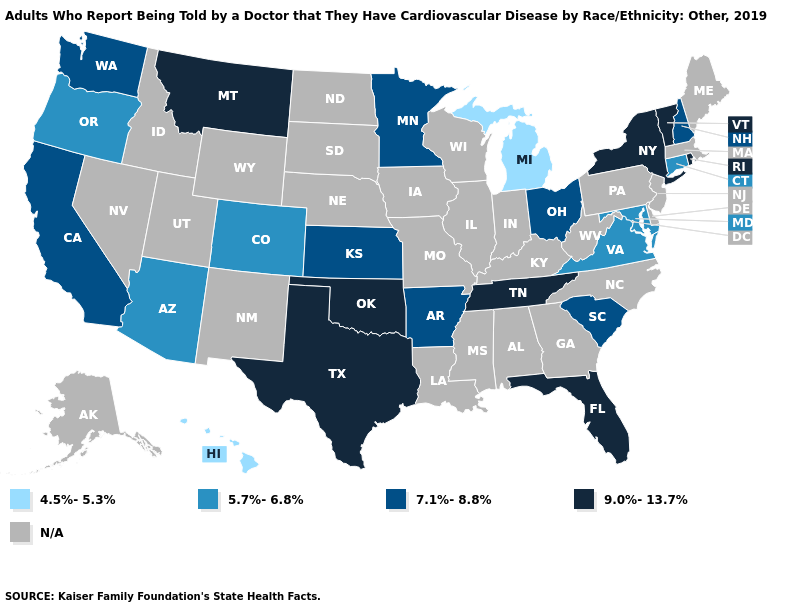What is the lowest value in the USA?
Be succinct. 4.5%-5.3%. Name the states that have a value in the range 7.1%-8.8%?
Concise answer only. Arkansas, California, Kansas, Minnesota, New Hampshire, Ohio, South Carolina, Washington. Does Minnesota have the lowest value in the MidWest?
Concise answer only. No. What is the value of Nebraska?
Be succinct. N/A. Name the states that have a value in the range 9.0%-13.7%?
Concise answer only. Florida, Montana, New York, Oklahoma, Rhode Island, Tennessee, Texas, Vermont. What is the value of Indiana?
Answer briefly. N/A. Does the map have missing data?
Write a very short answer. Yes. Name the states that have a value in the range 5.7%-6.8%?
Write a very short answer. Arizona, Colorado, Connecticut, Maryland, Oregon, Virginia. What is the highest value in states that border Rhode Island?
Answer briefly. 5.7%-6.8%. Does the first symbol in the legend represent the smallest category?
Short answer required. Yes. Name the states that have a value in the range 7.1%-8.8%?
Short answer required. Arkansas, California, Kansas, Minnesota, New Hampshire, Ohio, South Carolina, Washington. Does the first symbol in the legend represent the smallest category?
Concise answer only. Yes. 